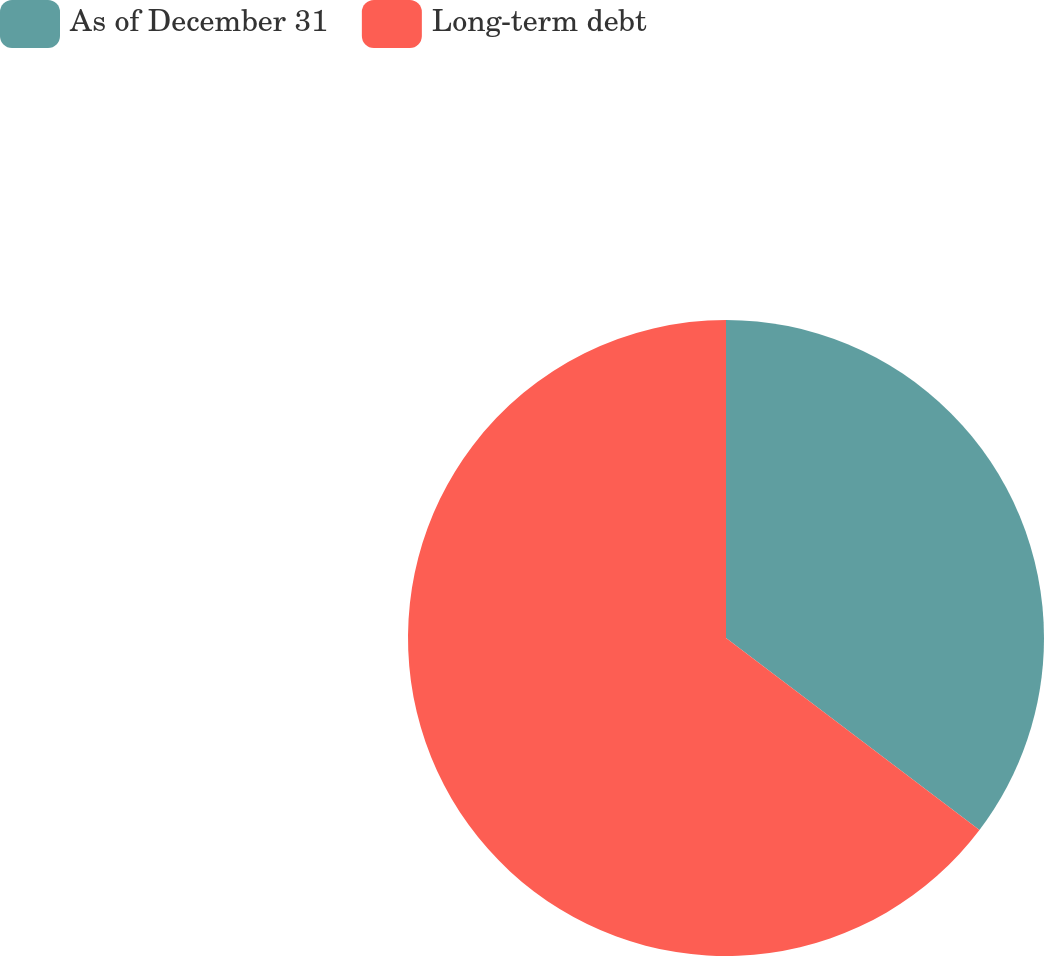Convert chart to OTSL. <chart><loc_0><loc_0><loc_500><loc_500><pie_chart><fcel>As of December 31<fcel>Long-term debt<nl><fcel>35.32%<fcel>64.68%<nl></chart> 